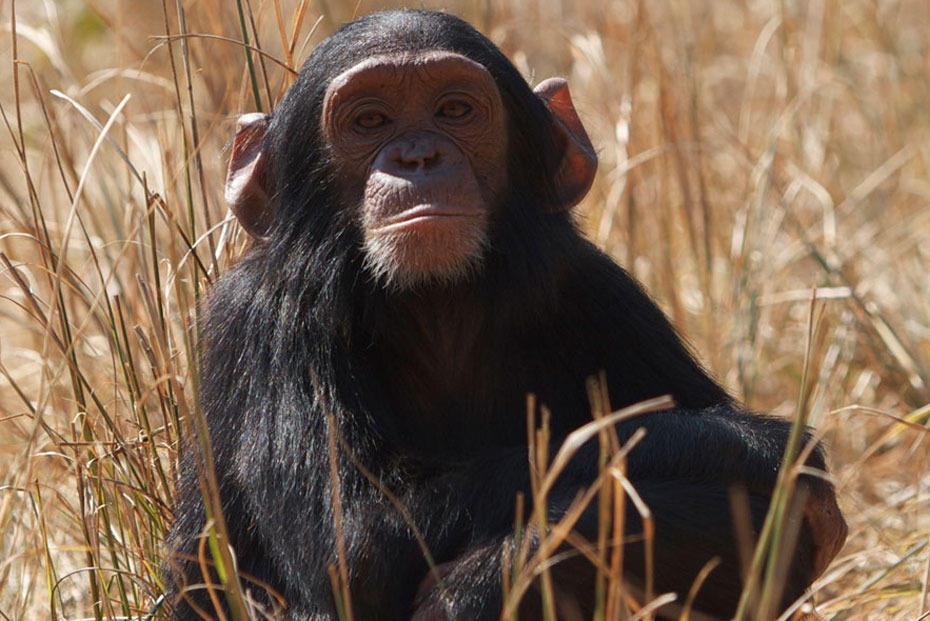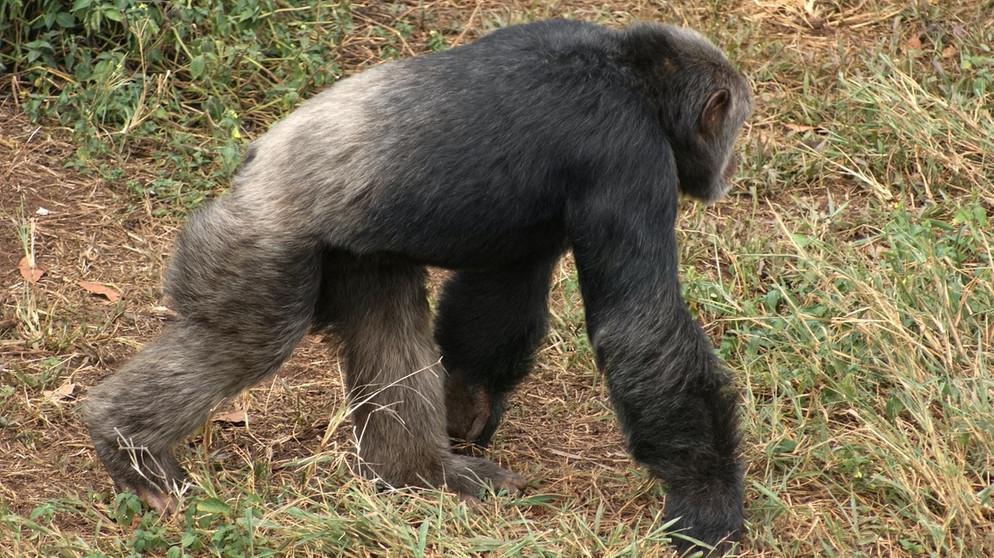The first image is the image on the left, the second image is the image on the right. For the images shown, is this caption "In one of the images there are exactly two chimpanzees laying down near each other.." true? Answer yes or no. No. The first image is the image on the left, the second image is the image on the right. Assess this claim about the two images: "Two primates are lying down in one of the images.". Correct or not? Answer yes or no. No. 